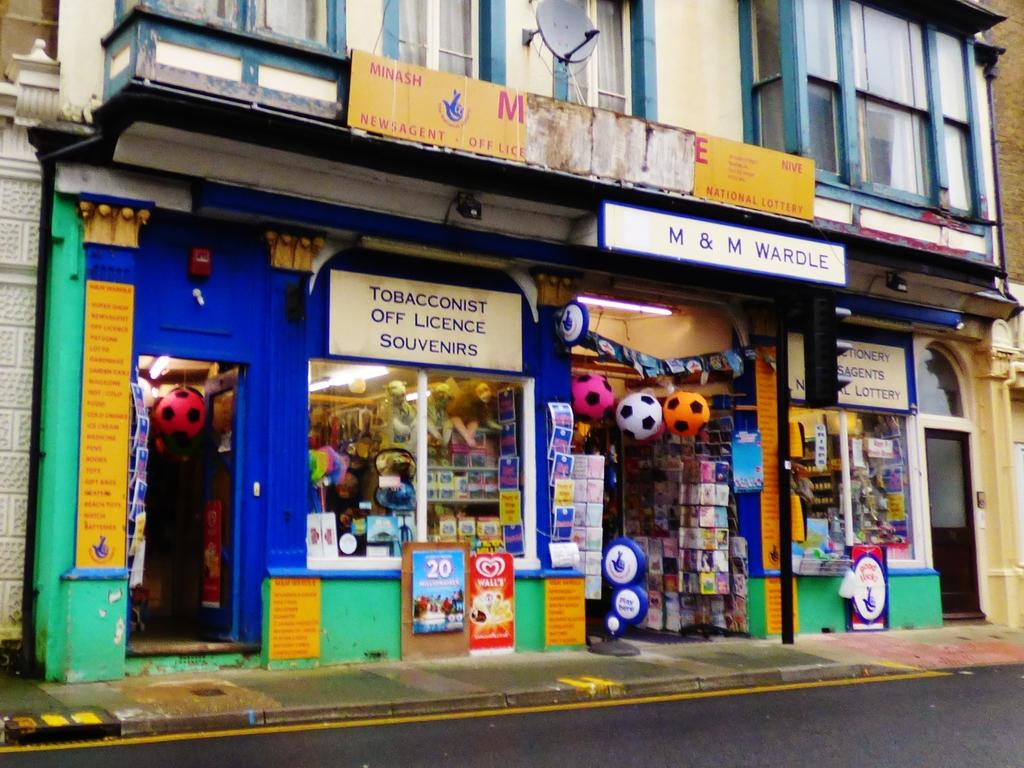<image>
Present a compact description of the photo's key features. A store on the street that says Tobacconist off licence souvenirs 